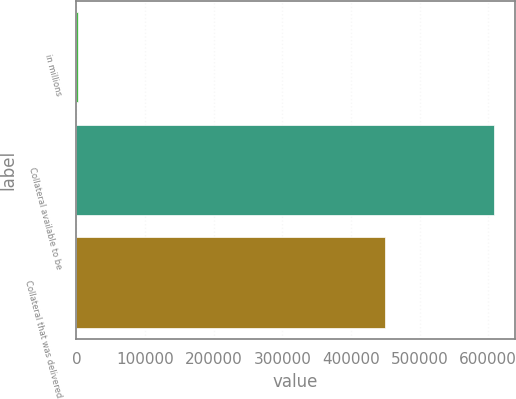Convert chart. <chart><loc_0><loc_0><loc_500><loc_500><bar_chart><fcel>in millions<fcel>Collateral available to be<fcel>Collateral that was delivered<nl><fcel>2013<fcel>608390<fcel>450127<nl></chart> 